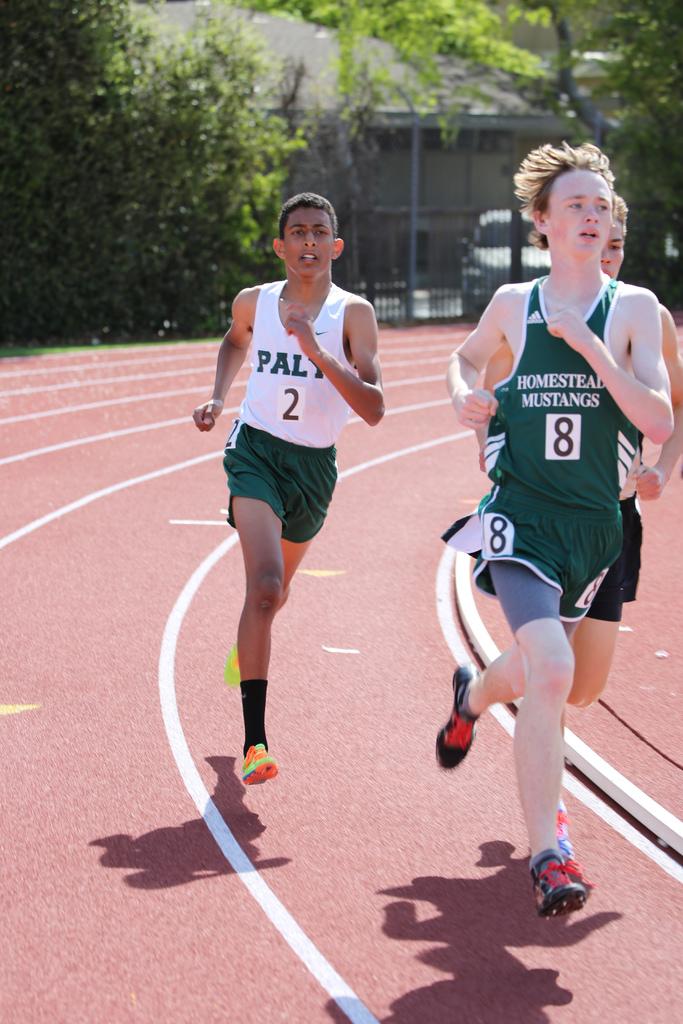What is the mascot of the athlete on the right?
Offer a terse response. Mustangs. What number is the athlete on the left?
Ensure brevity in your answer.  2. 